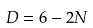<formula> <loc_0><loc_0><loc_500><loc_500>D = 6 - 2 N</formula> 